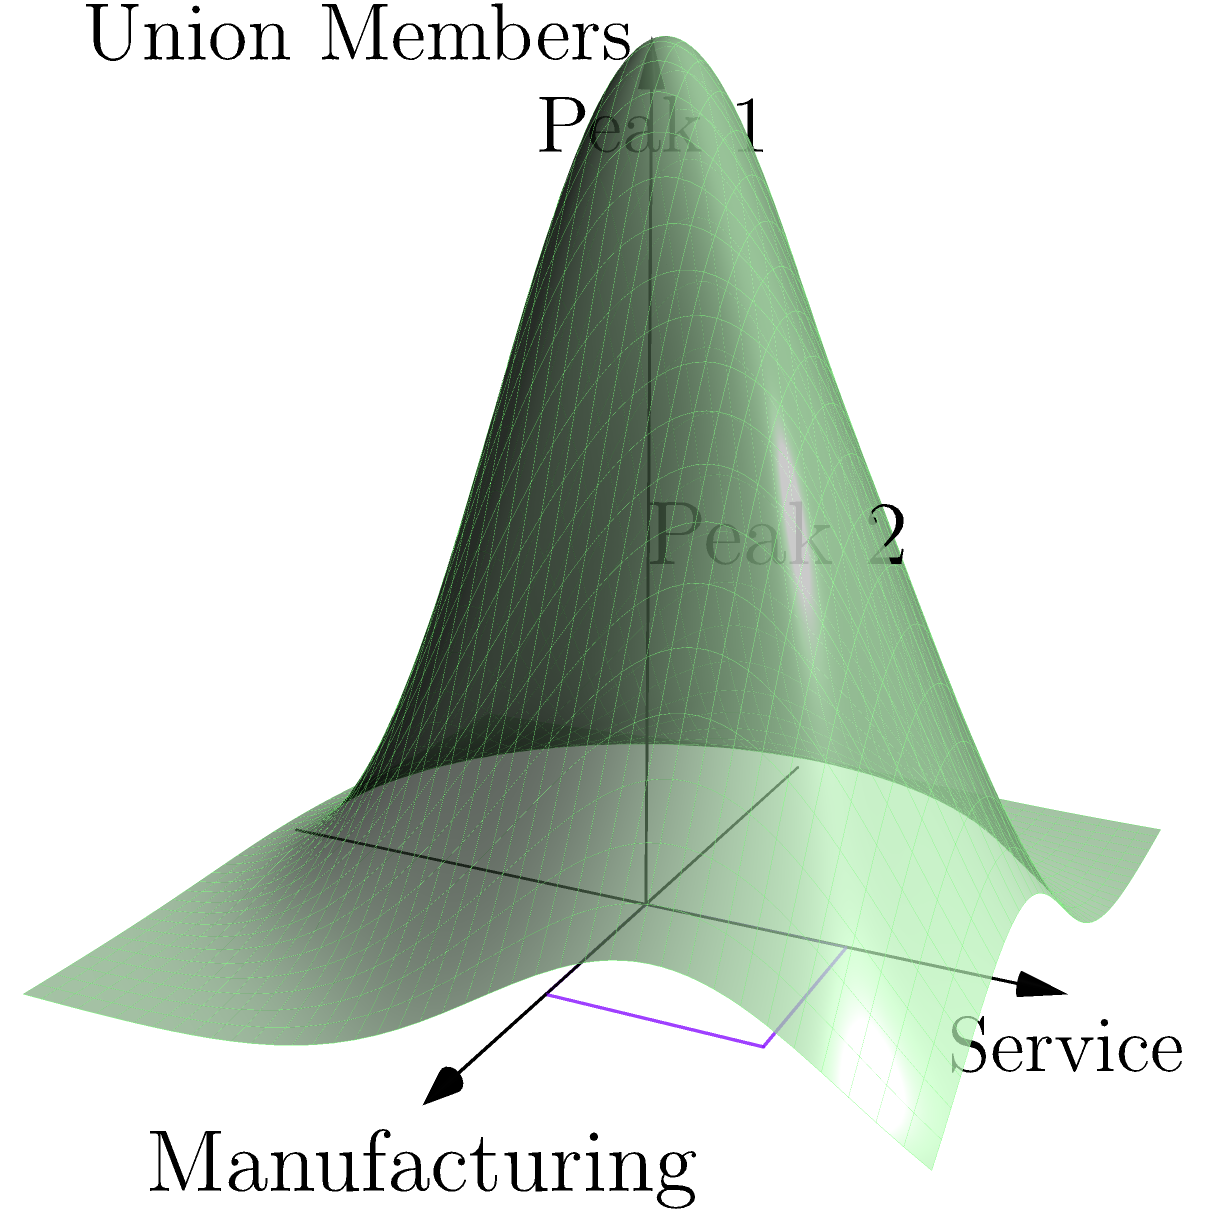In the 3D coordinate system shown, the x-axis represents the manufacturing sector, the y-axis represents the service sector, and the z-axis represents the number of union members. The surface plot shows the distribution of union members across these industries. What does the presence of two distinct peaks in the distribution suggest about union membership in these sectors? To interpret the 3D coordinate system and answer the question, let's analyze the graph step-by-step:

1. The x-axis represents the manufacturing sector, and the y-axis represents the service sector. The z-axis shows the number of union members.

2. The surface plot represents the distribution of union members across these two sectors.

3. There are two distinct peaks visible on the surface:
   a. Peak 1: Located at approximately (0, 0, 0.5)
   b. Peak 2: Located at approximately (1, 1, 0.3)

4. The presence of two peaks suggests that there are two areas of high union membership concentration in different parts of the industry spectrum.

5. Peak 1 is higher than Peak 2, indicating a larger concentration of union members in that area.

6. Peak 1's position (near 0, 0) suggests it represents industries that are neither purely manufacturing nor purely service-oriented, but a mix of both.

7. Peak 2's position (near 1, 1) suggests it represents industries that have a stronger presence in both manufacturing and service sectors.

8. The existence of two separate peaks rather than one central peak indicates that union membership is not evenly distributed across all industries, but tends to cluster in specific sectors.

9. The valleys between and around the peaks represent areas of lower union membership, possibly indicating industries or sectors where unionization is less common.

Given this analysis, the presence of two distinct peaks suggests that union membership is concentrated in two different types of industries: one that blends manufacturing and service elements, and another that has a stronger presence in both sectors. This implies a non-uniform distribution of union membership across industries and potentially reflects the historical strength of unions in certain sectors or the success of organizing efforts in specific industry clusters.
Answer: Concentration of union membership in two distinct industry clusters: one blending manufacturing and service, another with strong presence in both sectors. 